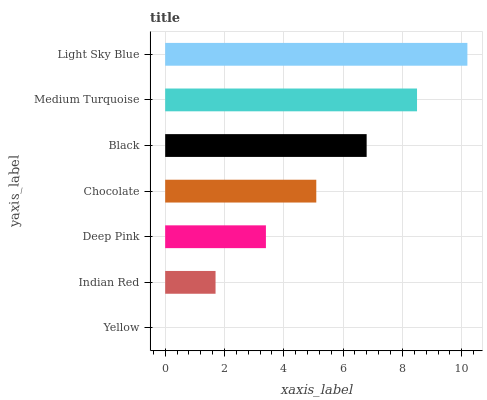Is Yellow the minimum?
Answer yes or no. Yes. Is Light Sky Blue the maximum?
Answer yes or no. Yes. Is Indian Red the minimum?
Answer yes or no. No. Is Indian Red the maximum?
Answer yes or no. No. Is Indian Red greater than Yellow?
Answer yes or no. Yes. Is Yellow less than Indian Red?
Answer yes or no. Yes. Is Yellow greater than Indian Red?
Answer yes or no. No. Is Indian Red less than Yellow?
Answer yes or no. No. Is Chocolate the high median?
Answer yes or no. Yes. Is Chocolate the low median?
Answer yes or no. Yes. Is Yellow the high median?
Answer yes or no. No. Is Yellow the low median?
Answer yes or no. No. 